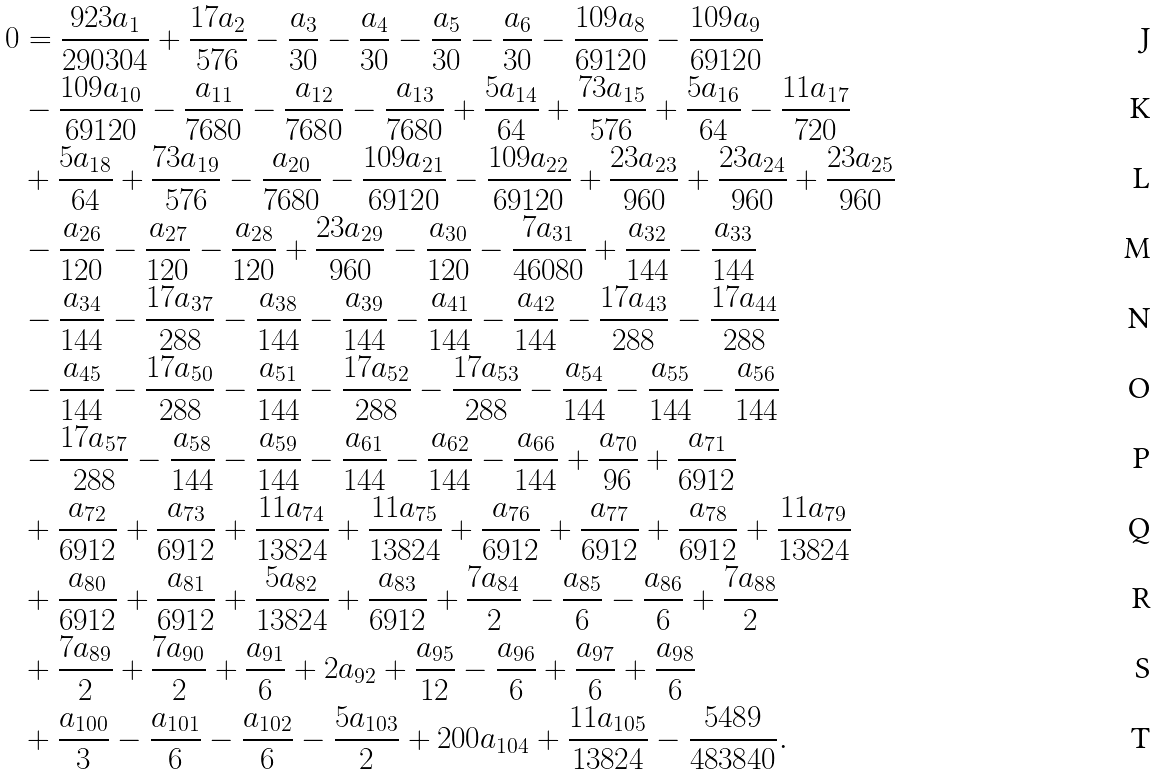Convert formula to latex. <formula><loc_0><loc_0><loc_500><loc_500>0 & = \frac { 9 2 3 a _ { 1 } } { 2 9 0 3 0 4 } + \frac { 1 7 a _ { 2 } } { 5 7 6 } - \frac { a _ { 3 } } { 3 0 } - \frac { a _ { 4 } } { 3 0 } - \frac { a _ { 5 } } { 3 0 } - \frac { a _ { 6 } } { 3 0 } - \frac { 1 0 9 a _ { 8 } } { 6 9 1 2 0 } - \frac { 1 0 9 a _ { 9 } } { 6 9 1 2 0 } \\ & - \frac { 1 0 9 a _ { 1 0 } } { 6 9 1 2 0 } - \frac { a _ { 1 1 } } { 7 6 8 0 } - \frac { a _ { 1 2 } } { 7 6 8 0 } - \frac { a _ { 1 3 } } { 7 6 8 0 } + \frac { 5 a _ { 1 4 } } { 6 4 } + \frac { 7 3 a _ { 1 5 } } { 5 7 6 } + \frac { 5 a _ { 1 6 } } { 6 4 } - \frac { 1 1 a _ { 1 7 } } { 7 2 0 } \\ & + \frac { 5 a _ { 1 8 } } { 6 4 } + \frac { 7 3 a _ { 1 9 } } { 5 7 6 } - \frac { a _ { 2 0 } } { 7 6 8 0 } - \frac { 1 0 9 a _ { 2 1 } } { 6 9 1 2 0 } - \frac { 1 0 9 a _ { 2 2 } } { 6 9 1 2 0 } + \frac { 2 3 a _ { 2 3 } } { 9 6 0 } + \frac { 2 3 a _ { 2 4 } } { 9 6 0 } + \frac { 2 3 a _ { 2 5 } } { 9 6 0 } \\ & - \frac { a _ { 2 6 } } { 1 2 0 } - \frac { a _ { 2 7 } } { 1 2 0 } - \frac { a _ { 2 8 } } { 1 2 0 } + \frac { 2 3 a _ { 2 9 } } { 9 6 0 } - \frac { a _ { 3 0 } } { 1 2 0 } - \frac { 7 a _ { 3 1 } } { 4 6 0 8 0 } + \frac { a _ { 3 2 } } { 1 4 4 } - \frac { a _ { 3 3 } } { 1 4 4 } \\ & - \frac { a _ { 3 4 } } { 1 4 4 } - \frac { 1 7 a _ { 3 7 } } { 2 8 8 } - \frac { a _ { 3 8 } } { 1 4 4 } - \frac { a _ { 3 9 } } { 1 4 4 } - \frac { a _ { 4 1 } } { 1 4 4 } - \frac { a _ { 4 2 } } { 1 4 4 } - \frac { 1 7 a _ { 4 3 } } { 2 8 8 } - \frac { 1 7 a _ { 4 4 } } { 2 8 8 } \\ & - \frac { a _ { 4 5 } } { 1 4 4 } - \frac { 1 7 a _ { 5 0 } } { 2 8 8 } - \frac { a _ { 5 1 } } { 1 4 4 } - \frac { 1 7 a _ { 5 2 } } { 2 8 8 } - \frac { 1 7 a _ { 5 3 } } { 2 8 8 } - \frac { a _ { 5 4 } } { 1 4 4 } - \frac { a _ { 5 5 } } { 1 4 4 } - \frac { a _ { 5 6 } } { 1 4 4 } \\ & - \frac { 1 7 a _ { 5 7 } } { 2 8 8 } - \frac { a _ { 5 8 } } { 1 4 4 } - \frac { a _ { 5 9 } } { 1 4 4 } - \frac { a _ { 6 1 } } { 1 4 4 } - \frac { a _ { 6 2 } } { 1 4 4 } - \frac { a _ { 6 6 } } { 1 4 4 } + \frac { a _ { 7 0 } } { 9 6 } + \frac { a _ { 7 1 } } { 6 9 1 2 } \\ & + \frac { a _ { 7 2 } } { 6 9 1 2 } + \frac { a _ { 7 3 } } { 6 9 1 2 } + \frac { 1 1 a _ { 7 4 } } { 1 3 8 2 4 } + \frac { 1 1 a _ { 7 5 } } { 1 3 8 2 4 } + \frac { a _ { 7 6 } } { 6 9 1 2 } + \frac { a _ { 7 7 } } { 6 9 1 2 } + \frac { a _ { 7 8 } } { 6 9 1 2 } + \frac { 1 1 a _ { 7 9 } } { 1 3 8 2 4 } \\ & + \frac { a _ { 8 0 } } { 6 9 1 2 } + \frac { a _ { 8 1 } } { 6 9 1 2 } + \frac { 5 a _ { 8 2 } } { 1 3 8 2 4 } + \frac { a _ { 8 3 } } { 6 9 1 2 } + \frac { 7 a _ { 8 4 } } { 2 } - \frac { a _ { 8 5 } } { 6 } - \frac { a _ { 8 6 } } { 6 } + \frac { 7 a _ { 8 8 } } { 2 } \\ & + \frac { 7 a _ { 8 9 } } { 2 } + \frac { 7 a _ { 9 0 } } { 2 } + \frac { a _ { 9 1 } } { 6 } + 2 a _ { 9 2 } + \frac { a _ { 9 5 } } { 1 2 } - \frac { a _ { 9 6 } } { 6 } + \frac { a _ { 9 7 } } { 6 } + \frac { a _ { 9 8 } } { 6 } \\ & + \frac { a _ { 1 0 0 } } { 3 } - \frac { a _ { 1 0 1 } } { 6 } - \frac { a _ { 1 0 2 } } { 6 } - \frac { 5 a _ { 1 0 3 } } { 2 } + 2 0 0 a _ { 1 0 4 } + \frac { 1 1 a _ { 1 0 5 } } { 1 3 8 2 4 } - \frac { 5 4 8 9 } { 4 8 3 8 4 0 } .</formula> 